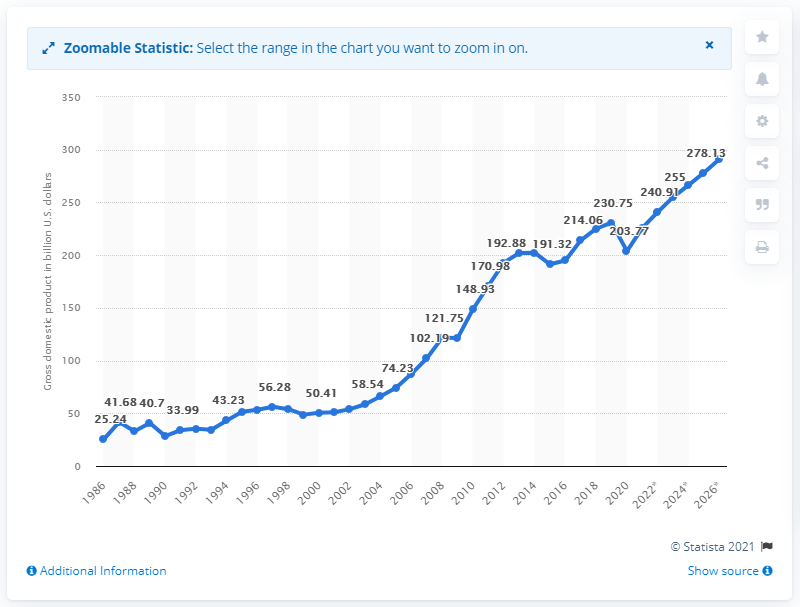Point out several critical features in this image. Peru's gross domestic product in dollars in 2020 was $203.77 billion. 